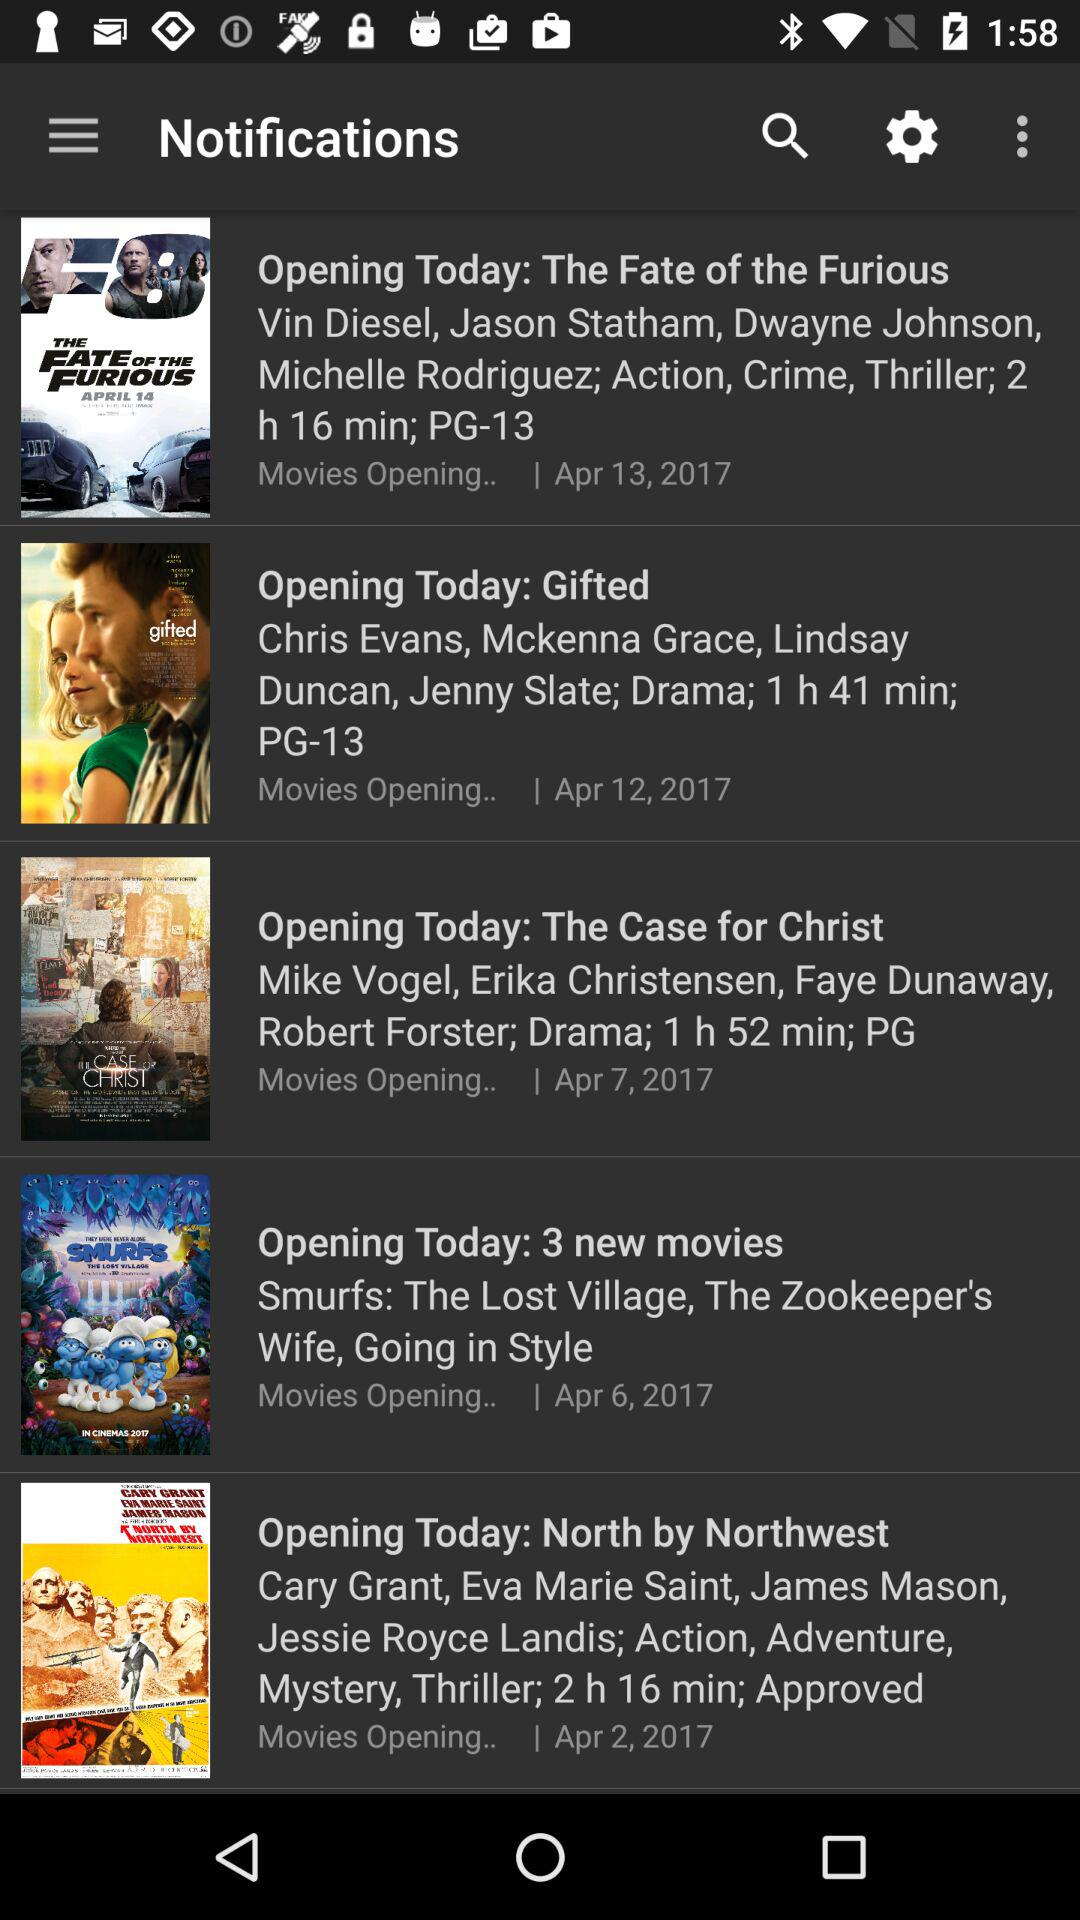What is the duration of the "North by Northwest" movie? The duration of the "North by Northwest" movie is 2 hours and 16 minutes. 